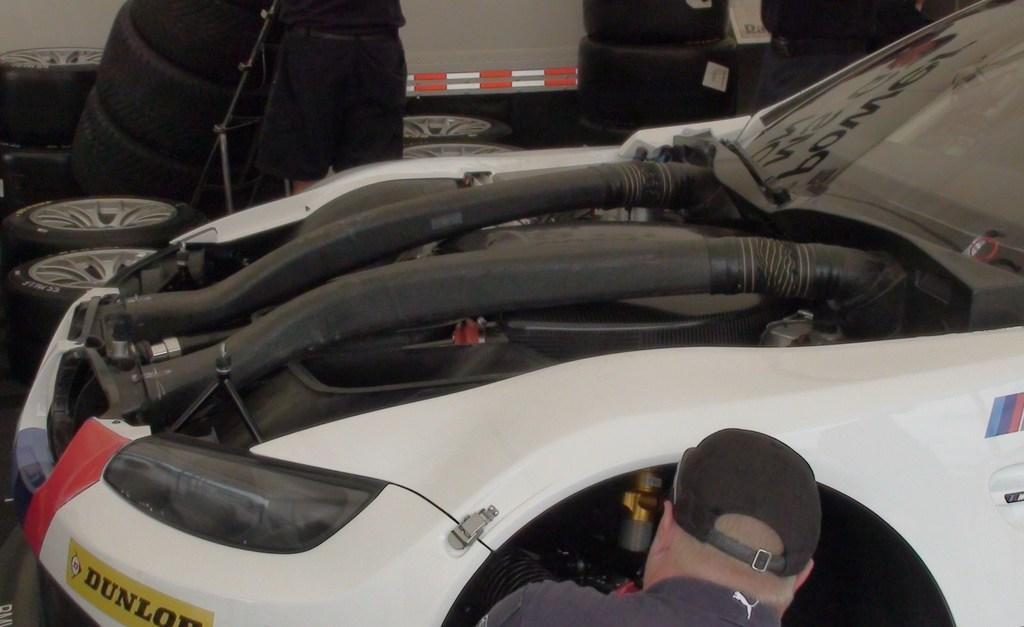In one or two sentences, can you explain what this image depicts? In this image we can see vehicle, tires, rods, board and people. 